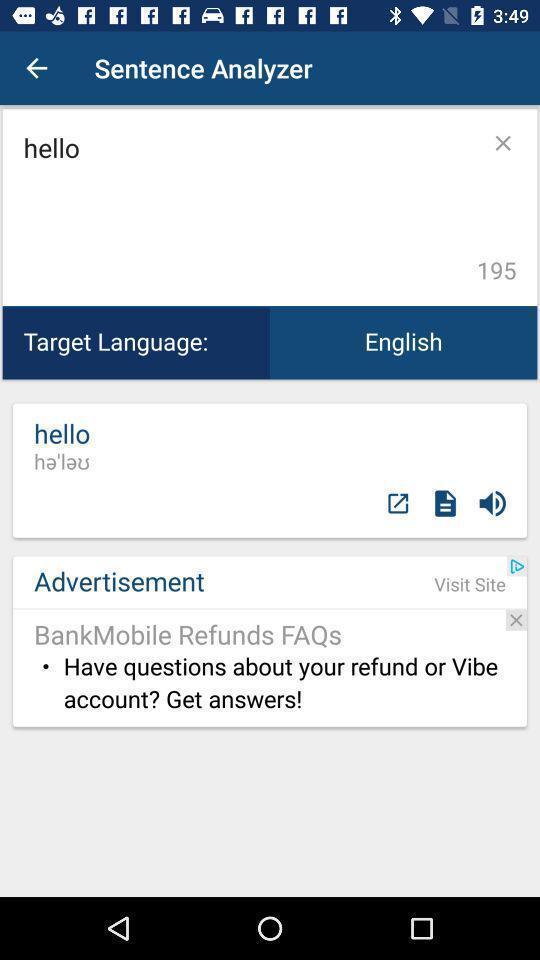Explain what's happening in this screen capture. Screen page of a translator app. 